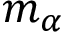<formula> <loc_0><loc_0><loc_500><loc_500>m _ { \alpha }</formula> 